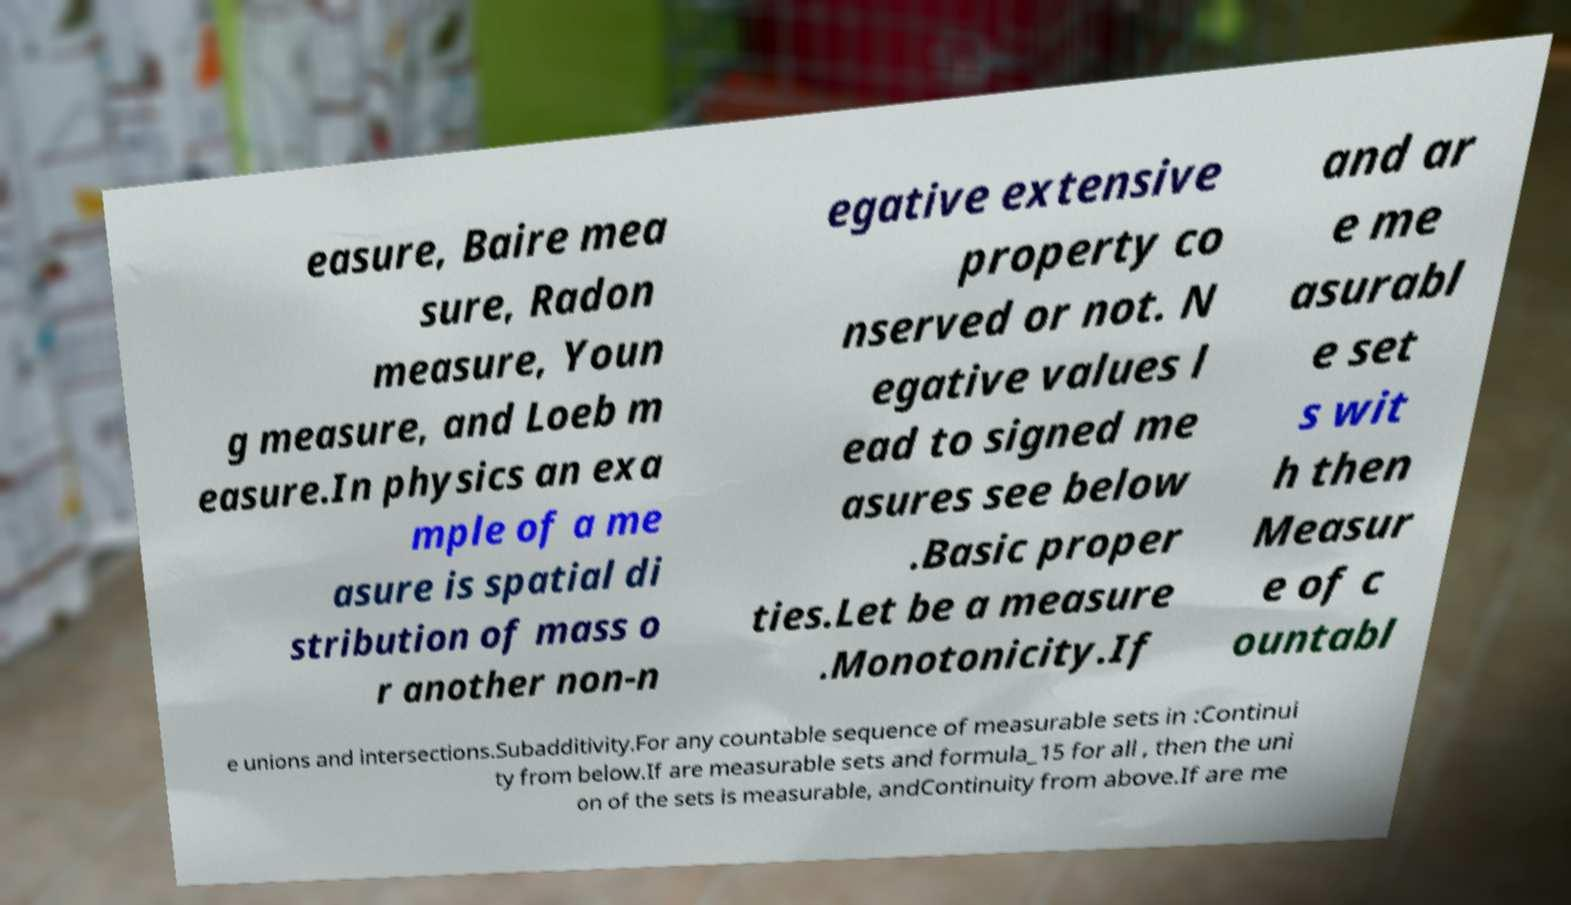Can you read and provide the text displayed in the image?This photo seems to have some interesting text. Can you extract and type it out for me? easure, Baire mea sure, Radon measure, Youn g measure, and Loeb m easure.In physics an exa mple of a me asure is spatial di stribution of mass o r another non-n egative extensive property co nserved or not. N egative values l ead to signed me asures see below .Basic proper ties.Let be a measure .Monotonicity.If and ar e me asurabl e set s wit h then Measur e of c ountabl e unions and intersections.Subadditivity.For any countable sequence of measurable sets in :Continui ty from below.If are measurable sets and formula_15 for all , then the uni on of the sets is measurable, andContinuity from above.If are me 